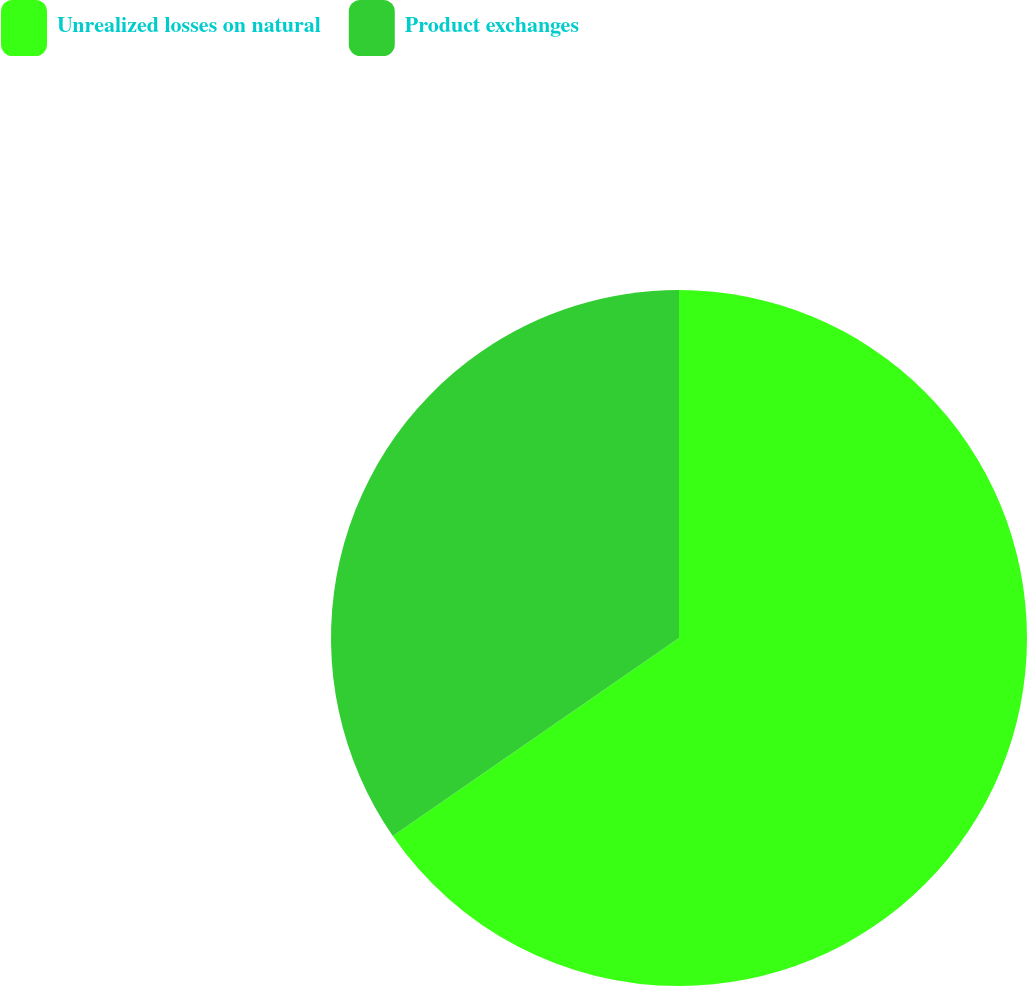<chart> <loc_0><loc_0><loc_500><loc_500><pie_chart><fcel>Unrealized losses on natural<fcel>Product exchanges<nl><fcel>65.37%<fcel>34.63%<nl></chart> 